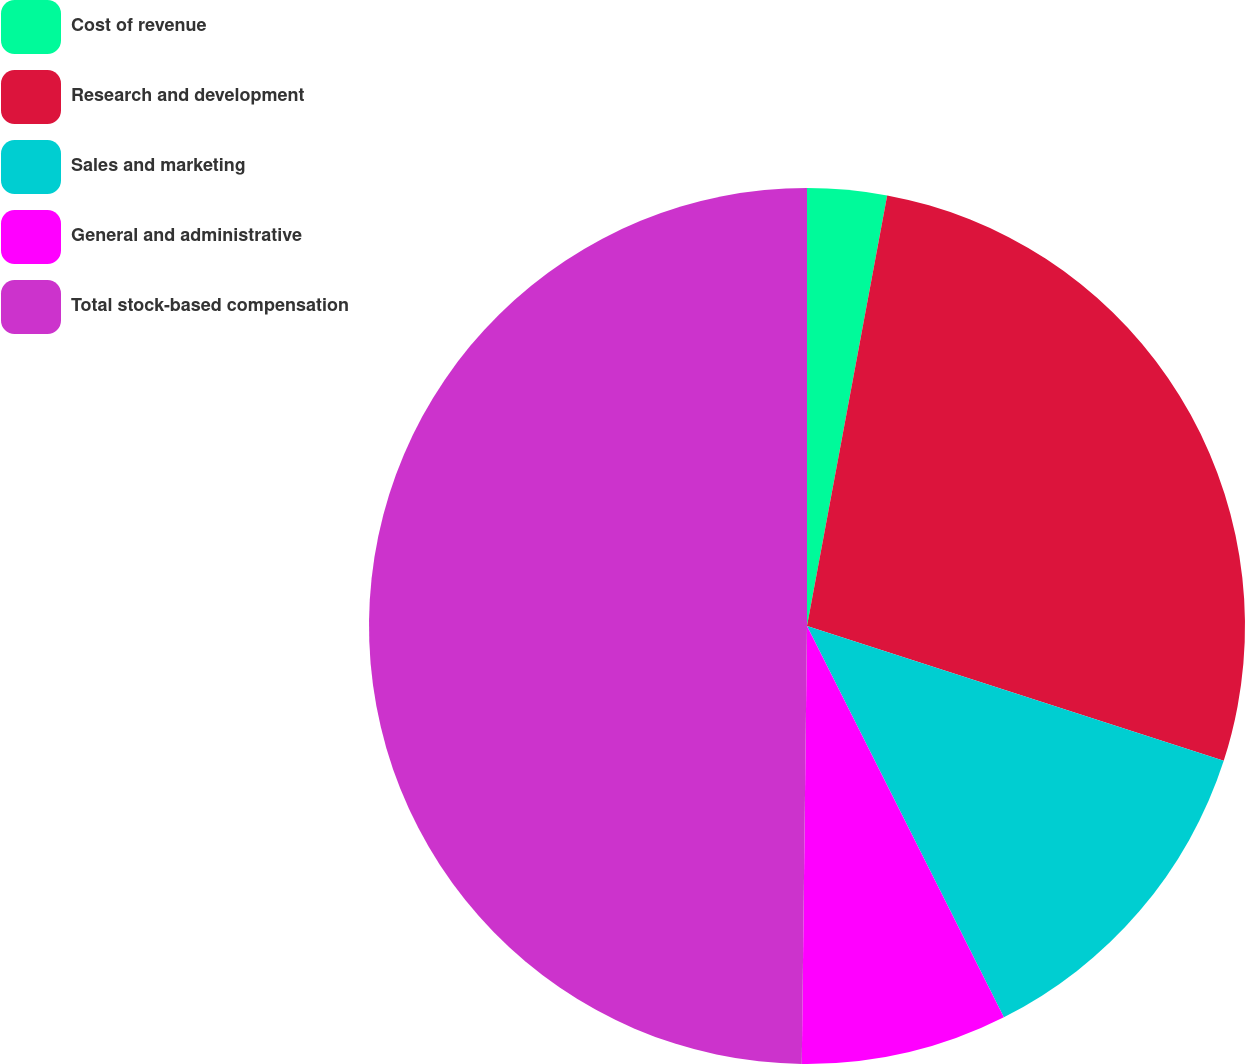Convert chart to OTSL. <chart><loc_0><loc_0><loc_500><loc_500><pie_chart><fcel>Cost of revenue<fcel>Research and development<fcel>Sales and marketing<fcel>General and administrative<fcel>Total stock-based compensation<nl><fcel>2.93%<fcel>27.05%<fcel>12.6%<fcel>7.61%<fcel>49.81%<nl></chart> 